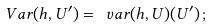<formula> <loc_0><loc_0><loc_500><loc_500>\ V a r ( h , U ^ { \prime } ) = \ v a r ( h , U ) ( U ^ { \prime } ) \, ;</formula> 